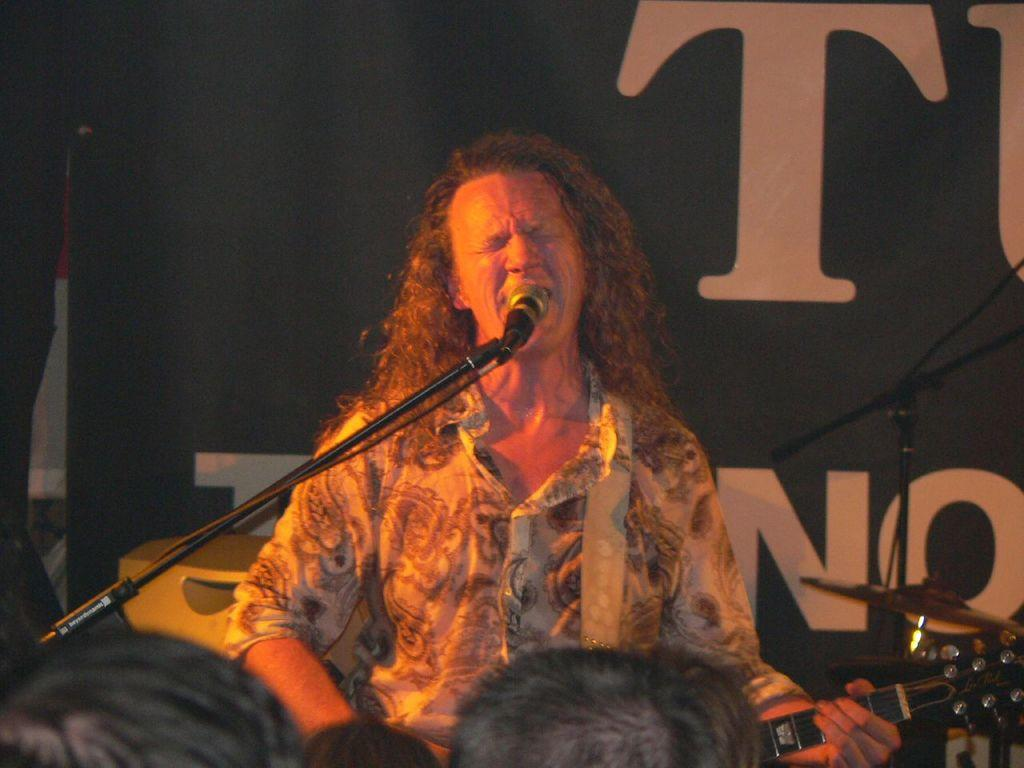What is the main subject of the image? There is a person in front of a mic in the image. Can you describe the people at the bottom of the image? There are people's heads visible at the bottom of the image. What other object can be seen in the image? There is a musical instrument in the bottom right of the image. What type of basin is being used to grow plants in the image? There is no basin or plants present in the image. How many potatoes can be seen in the image? There are no potatoes present in the image. 